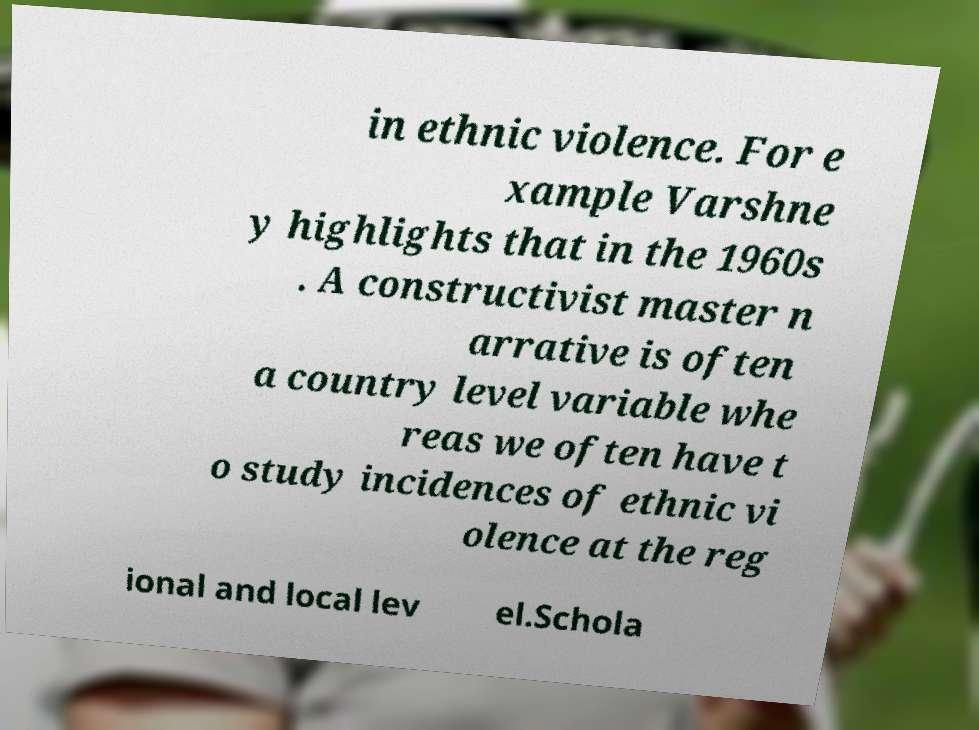Can you read and provide the text displayed in the image?This photo seems to have some interesting text. Can you extract and type it out for me? in ethnic violence. For e xample Varshne y highlights that in the 1960s . A constructivist master n arrative is often a country level variable whe reas we often have t o study incidences of ethnic vi olence at the reg ional and local lev el.Schola 